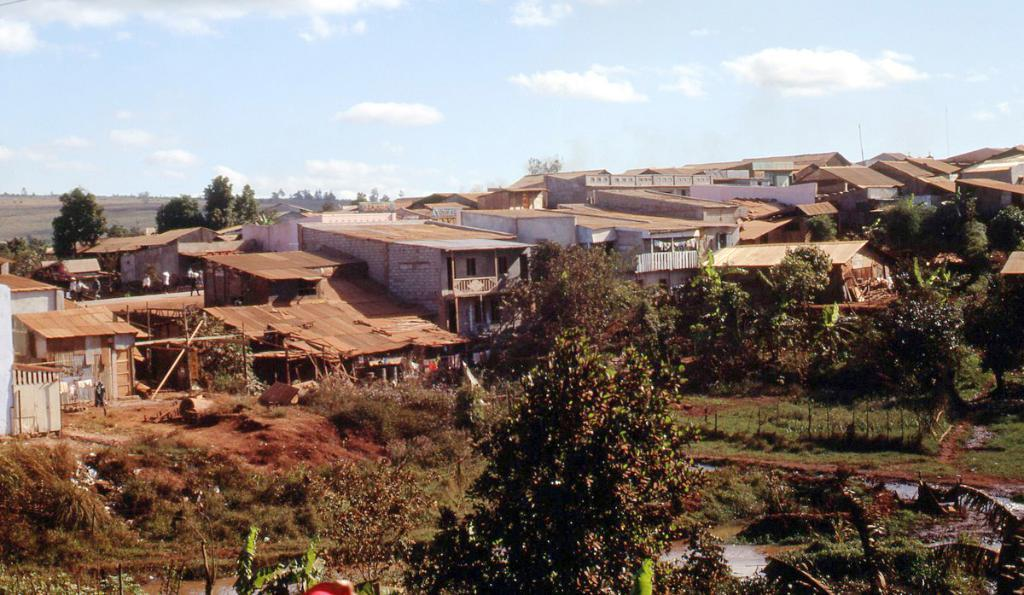What type of vegetation can be seen in the image? There are trees in the image. What type of structures are present in the image? There are houses in the image. What are the people in the image doing? The people in the image are on a path. What is visible behind the houses in the image? There is a sky visible behind the houses. What type of turkey can be seen in the image? There is no turkey present in the image. How much profit does the daughter make in the image? There is no mention of a daughter or profit in the image. 